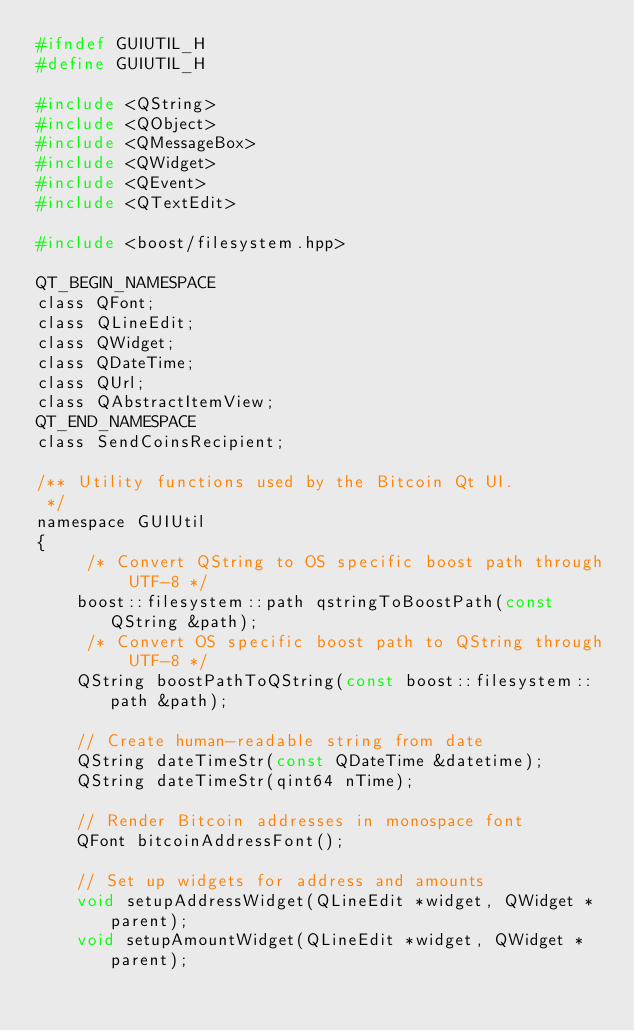Convert code to text. <code><loc_0><loc_0><loc_500><loc_500><_C_>#ifndef GUIUTIL_H
#define GUIUTIL_H

#include <QString>
#include <QObject>
#include <QMessageBox>
#include <QWidget>
#include <QEvent>
#include <QTextEdit>

#include <boost/filesystem.hpp>

QT_BEGIN_NAMESPACE
class QFont;
class QLineEdit;
class QWidget;
class QDateTime;
class QUrl;
class QAbstractItemView;
QT_END_NAMESPACE
class SendCoinsRecipient;

/** Utility functions used by the Bitcoin Qt UI.
 */
namespace GUIUtil
{
     /* Convert QString to OS specific boost path through UTF-8 */
    boost::filesystem::path qstringToBoostPath(const QString &path);
     /* Convert OS specific boost path to QString through UTF-8 */
    QString boostPathToQString(const boost::filesystem::path &path);

    // Create human-readable string from date
    QString dateTimeStr(const QDateTime &datetime);
    QString dateTimeStr(qint64 nTime);

    // Render Bitcoin addresses in monospace font
    QFont bitcoinAddressFont();

    // Set up widgets for address and amounts
    void setupAddressWidget(QLineEdit *widget, QWidget *parent);
    void setupAmountWidget(QLineEdit *widget, QWidget *parent);
</code> 